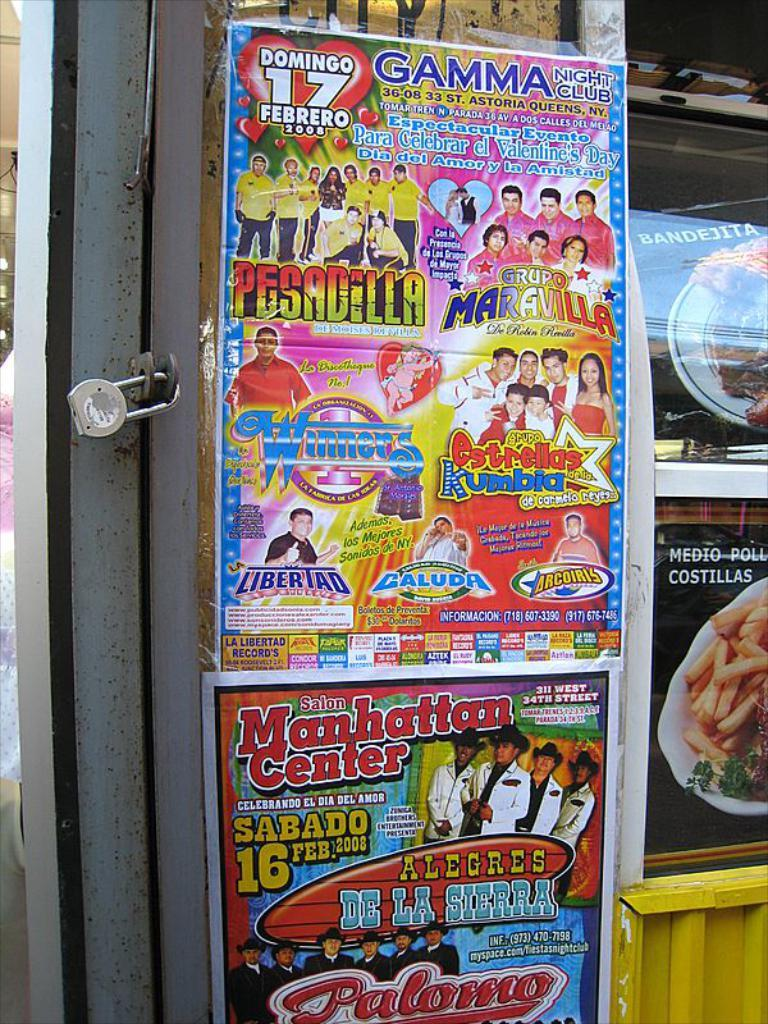What object can be seen in the image that is used for security? There is a lock in the image that is used for security. What type of decorations are present in the image? There are posters in the image. What can be seen on the posters? On the posters, there are people and food items depicted. What is written on the posters? There is text on the posters. What type of liquid can be seen flowing from the lock in the image? There is no liquid flowing from the lock in the image; it is a stationary object used for security. 